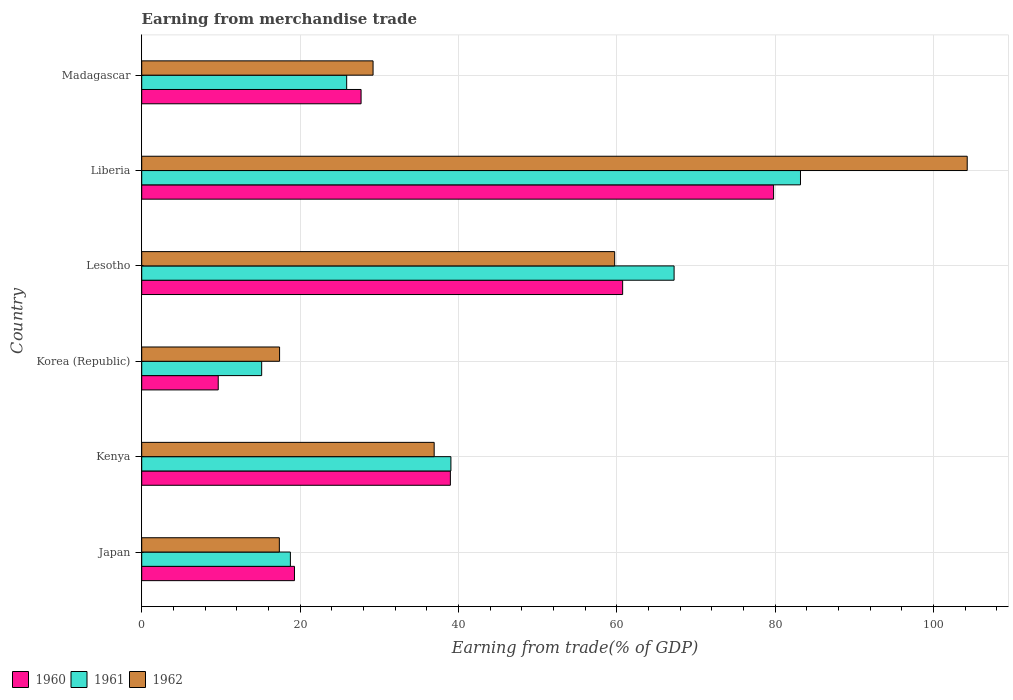How many different coloured bars are there?
Provide a short and direct response. 3. How many groups of bars are there?
Ensure brevity in your answer.  6. Are the number of bars per tick equal to the number of legend labels?
Give a very brief answer. Yes. Are the number of bars on each tick of the Y-axis equal?
Provide a short and direct response. Yes. How many bars are there on the 1st tick from the bottom?
Your answer should be compact. 3. What is the label of the 2nd group of bars from the top?
Make the answer very short. Liberia. What is the earnings from trade in 1960 in Lesotho?
Make the answer very short. 60.73. Across all countries, what is the maximum earnings from trade in 1961?
Ensure brevity in your answer.  83.19. Across all countries, what is the minimum earnings from trade in 1960?
Your response must be concise. 9.66. In which country was the earnings from trade in 1961 maximum?
Your answer should be very brief. Liberia. What is the total earnings from trade in 1961 in the graph?
Keep it short and to the point. 249.26. What is the difference between the earnings from trade in 1962 in Lesotho and that in Madagascar?
Make the answer very short. 30.51. What is the difference between the earnings from trade in 1962 in Lesotho and the earnings from trade in 1961 in Madagascar?
Provide a short and direct response. 33.84. What is the average earnings from trade in 1960 per country?
Provide a short and direct response. 39.36. What is the difference between the earnings from trade in 1961 and earnings from trade in 1960 in Lesotho?
Your response must be concise. 6.5. In how many countries, is the earnings from trade in 1961 greater than 40 %?
Your answer should be compact. 2. What is the ratio of the earnings from trade in 1961 in Japan to that in Korea (Republic)?
Give a very brief answer. 1.24. Is the earnings from trade in 1961 in Kenya less than that in Lesotho?
Provide a short and direct response. Yes. Is the difference between the earnings from trade in 1961 in Korea (Republic) and Liberia greater than the difference between the earnings from trade in 1960 in Korea (Republic) and Liberia?
Provide a succinct answer. Yes. What is the difference between the highest and the second highest earnings from trade in 1961?
Your response must be concise. 15.96. What is the difference between the highest and the lowest earnings from trade in 1962?
Offer a terse response. 86.86. Is the sum of the earnings from trade in 1962 in Japan and Kenya greater than the maximum earnings from trade in 1961 across all countries?
Offer a very short reply. No. What does the 3rd bar from the top in Liberia represents?
Offer a terse response. 1960. What does the 1st bar from the bottom in Liberia represents?
Provide a succinct answer. 1960. What is the difference between two consecutive major ticks on the X-axis?
Provide a short and direct response. 20. Does the graph contain grids?
Your answer should be very brief. Yes. Where does the legend appear in the graph?
Offer a terse response. Bottom left. What is the title of the graph?
Your response must be concise. Earning from merchandise trade. Does "2014" appear as one of the legend labels in the graph?
Provide a short and direct response. No. What is the label or title of the X-axis?
Ensure brevity in your answer.  Earning from trade(% of GDP). What is the label or title of the Y-axis?
Offer a terse response. Country. What is the Earning from trade(% of GDP) in 1960 in Japan?
Your answer should be compact. 19.29. What is the Earning from trade(% of GDP) in 1961 in Japan?
Ensure brevity in your answer.  18.77. What is the Earning from trade(% of GDP) of 1962 in Japan?
Give a very brief answer. 17.38. What is the Earning from trade(% of GDP) of 1960 in Kenya?
Ensure brevity in your answer.  38.98. What is the Earning from trade(% of GDP) in 1961 in Kenya?
Give a very brief answer. 39.04. What is the Earning from trade(% of GDP) of 1962 in Kenya?
Offer a very short reply. 36.93. What is the Earning from trade(% of GDP) of 1960 in Korea (Republic)?
Offer a terse response. 9.66. What is the Earning from trade(% of GDP) of 1961 in Korea (Republic)?
Offer a terse response. 15.15. What is the Earning from trade(% of GDP) of 1962 in Korea (Republic)?
Your answer should be compact. 17.41. What is the Earning from trade(% of GDP) in 1960 in Lesotho?
Keep it short and to the point. 60.73. What is the Earning from trade(% of GDP) in 1961 in Lesotho?
Offer a terse response. 67.23. What is the Earning from trade(% of GDP) of 1962 in Lesotho?
Ensure brevity in your answer.  59.72. What is the Earning from trade(% of GDP) in 1960 in Liberia?
Your answer should be compact. 79.79. What is the Earning from trade(% of GDP) in 1961 in Liberia?
Your response must be concise. 83.19. What is the Earning from trade(% of GDP) in 1962 in Liberia?
Offer a very short reply. 104.24. What is the Earning from trade(% of GDP) of 1960 in Madagascar?
Give a very brief answer. 27.7. What is the Earning from trade(% of GDP) of 1961 in Madagascar?
Your answer should be very brief. 25.88. What is the Earning from trade(% of GDP) in 1962 in Madagascar?
Offer a terse response. 29.21. Across all countries, what is the maximum Earning from trade(% of GDP) of 1960?
Ensure brevity in your answer.  79.79. Across all countries, what is the maximum Earning from trade(% of GDP) in 1961?
Offer a terse response. 83.19. Across all countries, what is the maximum Earning from trade(% of GDP) in 1962?
Give a very brief answer. 104.24. Across all countries, what is the minimum Earning from trade(% of GDP) in 1960?
Ensure brevity in your answer.  9.66. Across all countries, what is the minimum Earning from trade(% of GDP) in 1961?
Your answer should be very brief. 15.15. Across all countries, what is the minimum Earning from trade(% of GDP) in 1962?
Give a very brief answer. 17.38. What is the total Earning from trade(% of GDP) in 1960 in the graph?
Provide a short and direct response. 236.14. What is the total Earning from trade(% of GDP) in 1961 in the graph?
Keep it short and to the point. 249.26. What is the total Earning from trade(% of GDP) in 1962 in the graph?
Keep it short and to the point. 264.89. What is the difference between the Earning from trade(% of GDP) in 1960 in Japan and that in Kenya?
Your answer should be compact. -19.69. What is the difference between the Earning from trade(% of GDP) in 1961 in Japan and that in Kenya?
Make the answer very short. -20.27. What is the difference between the Earning from trade(% of GDP) in 1962 in Japan and that in Kenya?
Your answer should be compact. -19.55. What is the difference between the Earning from trade(% of GDP) in 1960 in Japan and that in Korea (Republic)?
Your answer should be compact. 9.63. What is the difference between the Earning from trade(% of GDP) of 1961 in Japan and that in Korea (Republic)?
Give a very brief answer. 3.63. What is the difference between the Earning from trade(% of GDP) of 1962 in Japan and that in Korea (Republic)?
Offer a very short reply. -0.03. What is the difference between the Earning from trade(% of GDP) of 1960 in Japan and that in Lesotho?
Offer a very short reply. -41.44. What is the difference between the Earning from trade(% of GDP) in 1961 in Japan and that in Lesotho?
Ensure brevity in your answer.  -48.45. What is the difference between the Earning from trade(% of GDP) in 1962 in Japan and that in Lesotho?
Provide a short and direct response. -42.34. What is the difference between the Earning from trade(% of GDP) in 1960 in Japan and that in Liberia?
Make the answer very short. -60.5. What is the difference between the Earning from trade(% of GDP) of 1961 in Japan and that in Liberia?
Provide a succinct answer. -64.41. What is the difference between the Earning from trade(% of GDP) in 1962 in Japan and that in Liberia?
Keep it short and to the point. -86.86. What is the difference between the Earning from trade(% of GDP) in 1960 in Japan and that in Madagascar?
Your answer should be compact. -8.41. What is the difference between the Earning from trade(% of GDP) of 1961 in Japan and that in Madagascar?
Give a very brief answer. -7.11. What is the difference between the Earning from trade(% of GDP) in 1962 in Japan and that in Madagascar?
Provide a succinct answer. -11.84. What is the difference between the Earning from trade(% of GDP) of 1960 in Kenya and that in Korea (Republic)?
Make the answer very short. 29.31. What is the difference between the Earning from trade(% of GDP) in 1961 in Kenya and that in Korea (Republic)?
Offer a very short reply. 23.9. What is the difference between the Earning from trade(% of GDP) of 1962 in Kenya and that in Korea (Republic)?
Your answer should be very brief. 19.52. What is the difference between the Earning from trade(% of GDP) in 1960 in Kenya and that in Lesotho?
Provide a succinct answer. -21.75. What is the difference between the Earning from trade(% of GDP) of 1961 in Kenya and that in Lesotho?
Provide a succinct answer. -28.18. What is the difference between the Earning from trade(% of GDP) of 1962 in Kenya and that in Lesotho?
Provide a succinct answer. -22.79. What is the difference between the Earning from trade(% of GDP) of 1960 in Kenya and that in Liberia?
Offer a very short reply. -40.82. What is the difference between the Earning from trade(% of GDP) of 1961 in Kenya and that in Liberia?
Offer a terse response. -44.14. What is the difference between the Earning from trade(% of GDP) in 1962 in Kenya and that in Liberia?
Offer a terse response. -67.31. What is the difference between the Earning from trade(% of GDP) of 1960 in Kenya and that in Madagascar?
Keep it short and to the point. 11.28. What is the difference between the Earning from trade(% of GDP) in 1961 in Kenya and that in Madagascar?
Ensure brevity in your answer.  13.16. What is the difference between the Earning from trade(% of GDP) in 1962 in Kenya and that in Madagascar?
Your answer should be compact. 7.72. What is the difference between the Earning from trade(% of GDP) in 1960 in Korea (Republic) and that in Lesotho?
Ensure brevity in your answer.  -51.07. What is the difference between the Earning from trade(% of GDP) of 1961 in Korea (Republic) and that in Lesotho?
Your response must be concise. -52.08. What is the difference between the Earning from trade(% of GDP) in 1962 in Korea (Republic) and that in Lesotho?
Make the answer very short. -42.32. What is the difference between the Earning from trade(% of GDP) of 1960 in Korea (Republic) and that in Liberia?
Ensure brevity in your answer.  -70.13. What is the difference between the Earning from trade(% of GDP) of 1961 in Korea (Republic) and that in Liberia?
Offer a terse response. -68.04. What is the difference between the Earning from trade(% of GDP) of 1962 in Korea (Republic) and that in Liberia?
Keep it short and to the point. -86.83. What is the difference between the Earning from trade(% of GDP) in 1960 in Korea (Republic) and that in Madagascar?
Provide a short and direct response. -18.04. What is the difference between the Earning from trade(% of GDP) in 1961 in Korea (Republic) and that in Madagascar?
Your response must be concise. -10.74. What is the difference between the Earning from trade(% of GDP) of 1962 in Korea (Republic) and that in Madagascar?
Give a very brief answer. -11.81. What is the difference between the Earning from trade(% of GDP) in 1960 in Lesotho and that in Liberia?
Your answer should be compact. -19.06. What is the difference between the Earning from trade(% of GDP) in 1961 in Lesotho and that in Liberia?
Keep it short and to the point. -15.96. What is the difference between the Earning from trade(% of GDP) in 1962 in Lesotho and that in Liberia?
Provide a short and direct response. -44.52. What is the difference between the Earning from trade(% of GDP) of 1960 in Lesotho and that in Madagascar?
Keep it short and to the point. 33.03. What is the difference between the Earning from trade(% of GDP) in 1961 in Lesotho and that in Madagascar?
Your answer should be compact. 41.35. What is the difference between the Earning from trade(% of GDP) of 1962 in Lesotho and that in Madagascar?
Keep it short and to the point. 30.51. What is the difference between the Earning from trade(% of GDP) in 1960 in Liberia and that in Madagascar?
Your answer should be very brief. 52.09. What is the difference between the Earning from trade(% of GDP) in 1961 in Liberia and that in Madagascar?
Provide a short and direct response. 57.31. What is the difference between the Earning from trade(% of GDP) in 1962 in Liberia and that in Madagascar?
Give a very brief answer. 75.03. What is the difference between the Earning from trade(% of GDP) of 1960 in Japan and the Earning from trade(% of GDP) of 1961 in Kenya?
Keep it short and to the point. -19.76. What is the difference between the Earning from trade(% of GDP) in 1960 in Japan and the Earning from trade(% of GDP) in 1962 in Kenya?
Keep it short and to the point. -17.64. What is the difference between the Earning from trade(% of GDP) in 1961 in Japan and the Earning from trade(% of GDP) in 1962 in Kenya?
Your answer should be very brief. -18.16. What is the difference between the Earning from trade(% of GDP) of 1960 in Japan and the Earning from trade(% of GDP) of 1961 in Korea (Republic)?
Keep it short and to the point. 4.14. What is the difference between the Earning from trade(% of GDP) of 1960 in Japan and the Earning from trade(% of GDP) of 1962 in Korea (Republic)?
Your answer should be compact. 1.88. What is the difference between the Earning from trade(% of GDP) in 1961 in Japan and the Earning from trade(% of GDP) in 1962 in Korea (Republic)?
Provide a short and direct response. 1.37. What is the difference between the Earning from trade(% of GDP) of 1960 in Japan and the Earning from trade(% of GDP) of 1961 in Lesotho?
Give a very brief answer. -47.94. What is the difference between the Earning from trade(% of GDP) of 1960 in Japan and the Earning from trade(% of GDP) of 1962 in Lesotho?
Provide a succinct answer. -40.44. What is the difference between the Earning from trade(% of GDP) in 1961 in Japan and the Earning from trade(% of GDP) in 1962 in Lesotho?
Offer a terse response. -40.95. What is the difference between the Earning from trade(% of GDP) in 1960 in Japan and the Earning from trade(% of GDP) in 1961 in Liberia?
Give a very brief answer. -63.9. What is the difference between the Earning from trade(% of GDP) of 1960 in Japan and the Earning from trade(% of GDP) of 1962 in Liberia?
Make the answer very short. -84.95. What is the difference between the Earning from trade(% of GDP) of 1961 in Japan and the Earning from trade(% of GDP) of 1962 in Liberia?
Your response must be concise. -85.47. What is the difference between the Earning from trade(% of GDP) of 1960 in Japan and the Earning from trade(% of GDP) of 1961 in Madagascar?
Provide a short and direct response. -6.59. What is the difference between the Earning from trade(% of GDP) in 1960 in Japan and the Earning from trade(% of GDP) in 1962 in Madagascar?
Your answer should be very brief. -9.93. What is the difference between the Earning from trade(% of GDP) in 1961 in Japan and the Earning from trade(% of GDP) in 1962 in Madagascar?
Keep it short and to the point. -10.44. What is the difference between the Earning from trade(% of GDP) in 1960 in Kenya and the Earning from trade(% of GDP) in 1961 in Korea (Republic)?
Make the answer very short. 23.83. What is the difference between the Earning from trade(% of GDP) of 1960 in Kenya and the Earning from trade(% of GDP) of 1962 in Korea (Republic)?
Provide a succinct answer. 21.57. What is the difference between the Earning from trade(% of GDP) in 1961 in Kenya and the Earning from trade(% of GDP) in 1962 in Korea (Republic)?
Give a very brief answer. 21.64. What is the difference between the Earning from trade(% of GDP) of 1960 in Kenya and the Earning from trade(% of GDP) of 1961 in Lesotho?
Offer a terse response. -28.25. What is the difference between the Earning from trade(% of GDP) of 1960 in Kenya and the Earning from trade(% of GDP) of 1962 in Lesotho?
Provide a succinct answer. -20.75. What is the difference between the Earning from trade(% of GDP) of 1961 in Kenya and the Earning from trade(% of GDP) of 1962 in Lesotho?
Your answer should be very brief. -20.68. What is the difference between the Earning from trade(% of GDP) of 1960 in Kenya and the Earning from trade(% of GDP) of 1961 in Liberia?
Provide a short and direct response. -44.21. What is the difference between the Earning from trade(% of GDP) of 1960 in Kenya and the Earning from trade(% of GDP) of 1962 in Liberia?
Your answer should be very brief. -65.27. What is the difference between the Earning from trade(% of GDP) in 1961 in Kenya and the Earning from trade(% of GDP) in 1962 in Liberia?
Your answer should be compact. -65.2. What is the difference between the Earning from trade(% of GDP) in 1960 in Kenya and the Earning from trade(% of GDP) in 1961 in Madagascar?
Your answer should be very brief. 13.09. What is the difference between the Earning from trade(% of GDP) of 1960 in Kenya and the Earning from trade(% of GDP) of 1962 in Madagascar?
Provide a succinct answer. 9.76. What is the difference between the Earning from trade(% of GDP) in 1961 in Kenya and the Earning from trade(% of GDP) in 1962 in Madagascar?
Offer a very short reply. 9.83. What is the difference between the Earning from trade(% of GDP) of 1960 in Korea (Republic) and the Earning from trade(% of GDP) of 1961 in Lesotho?
Offer a very short reply. -57.57. What is the difference between the Earning from trade(% of GDP) of 1960 in Korea (Republic) and the Earning from trade(% of GDP) of 1962 in Lesotho?
Your answer should be very brief. -50.06. What is the difference between the Earning from trade(% of GDP) of 1961 in Korea (Republic) and the Earning from trade(% of GDP) of 1962 in Lesotho?
Your answer should be very brief. -44.58. What is the difference between the Earning from trade(% of GDP) in 1960 in Korea (Republic) and the Earning from trade(% of GDP) in 1961 in Liberia?
Offer a very short reply. -73.53. What is the difference between the Earning from trade(% of GDP) of 1960 in Korea (Republic) and the Earning from trade(% of GDP) of 1962 in Liberia?
Your response must be concise. -94.58. What is the difference between the Earning from trade(% of GDP) in 1961 in Korea (Republic) and the Earning from trade(% of GDP) in 1962 in Liberia?
Ensure brevity in your answer.  -89.1. What is the difference between the Earning from trade(% of GDP) in 1960 in Korea (Republic) and the Earning from trade(% of GDP) in 1961 in Madagascar?
Provide a short and direct response. -16.22. What is the difference between the Earning from trade(% of GDP) of 1960 in Korea (Republic) and the Earning from trade(% of GDP) of 1962 in Madagascar?
Keep it short and to the point. -19.55. What is the difference between the Earning from trade(% of GDP) in 1961 in Korea (Republic) and the Earning from trade(% of GDP) in 1962 in Madagascar?
Your answer should be very brief. -14.07. What is the difference between the Earning from trade(% of GDP) in 1960 in Lesotho and the Earning from trade(% of GDP) in 1961 in Liberia?
Ensure brevity in your answer.  -22.46. What is the difference between the Earning from trade(% of GDP) in 1960 in Lesotho and the Earning from trade(% of GDP) in 1962 in Liberia?
Keep it short and to the point. -43.51. What is the difference between the Earning from trade(% of GDP) of 1961 in Lesotho and the Earning from trade(% of GDP) of 1962 in Liberia?
Your answer should be very brief. -37.01. What is the difference between the Earning from trade(% of GDP) of 1960 in Lesotho and the Earning from trade(% of GDP) of 1961 in Madagascar?
Ensure brevity in your answer.  34.85. What is the difference between the Earning from trade(% of GDP) of 1960 in Lesotho and the Earning from trade(% of GDP) of 1962 in Madagascar?
Your answer should be compact. 31.51. What is the difference between the Earning from trade(% of GDP) in 1961 in Lesotho and the Earning from trade(% of GDP) in 1962 in Madagascar?
Your answer should be compact. 38.01. What is the difference between the Earning from trade(% of GDP) in 1960 in Liberia and the Earning from trade(% of GDP) in 1961 in Madagascar?
Provide a short and direct response. 53.91. What is the difference between the Earning from trade(% of GDP) in 1960 in Liberia and the Earning from trade(% of GDP) in 1962 in Madagascar?
Provide a succinct answer. 50.58. What is the difference between the Earning from trade(% of GDP) of 1961 in Liberia and the Earning from trade(% of GDP) of 1962 in Madagascar?
Ensure brevity in your answer.  53.97. What is the average Earning from trade(% of GDP) in 1960 per country?
Offer a very short reply. 39.36. What is the average Earning from trade(% of GDP) in 1961 per country?
Provide a short and direct response. 41.54. What is the average Earning from trade(% of GDP) in 1962 per country?
Your answer should be very brief. 44.15. What is the difference between the Earning from trade(% of GDP) of 1960 and Earning from trade(% of GDP) of 1961 in Japan?
Provide a short and direct response. 0.51. What is the difference between the Earning from trade(% of GDP) of 1960 and Earning from trade(% of GDP) of 1962 in Japan?
Offer a very short reply. 1.91. What is the difference between the Earning from trade(% of GDP) in 1961 and Earning from trade(% of GDP) in 1962 in Japan?
Your response must be concise. 1.4. What is the difference between the Earning from trade(% of GDP) of 1960 and Earning from trade(% of GDP) of 1961 in Kenya?
Your answer should be compact. -0.07. What is the difference between the Earning from trade(% of GDP) in 1960 and Earning from trade(% of GDP) in 1962 in Kenya?
Your response must be concise. 2.04. What is the difference between the Earning from trade(% of GDP) in 1961 and Earning from trade(% of GDP) in 1962 in Kenya?
Ensure brevity in your answer.  2.11. What is the difference between the Earning from trade(% of GDP) of 1960 and Earning from trade(% of GDP) of 1961 in Korea (Republic)?
Offer a terse response. -5.48. What is the difference between the Earning from trade(% of GDP) in 1960 and Earning from trade(% of GDP) in 1962 in Korea (Republic)?
Give a very brief answer. -7.75. What is the difference between the Earning from trade(% of GDP) in 1961 and Earning from trade(% of GDP) in 1962 in Korea (Republic)?
Ensure brevity in your answer.  -2.26. What is the difference between the Earning from trade(% of GDP) of 1960 and Earning from trade(% of GDP) of 1961 in Lesotho?
Keep it short and to the point. -6.5. What is the difference between the Earning from trade(% of GDP) of 1960 and Earning from trade(% of GDP) of 1962 in Lesotho?
Provide a succinct answer. 1.01. What is the difference between the Earning from trade(% of GDP) in 1961 and Earning from trade(% of GDP) in 1962 in Lesotho?
Offer a terse response. 7.5. What is the difference between the Earning from trade(% of GDP) in 1960 and Earning from trade(% of GDP) in 1961 in Liberia?
Your response must be concise. -3.4. What is the difference between the Earning from trade(% of GDP) in 1960 and Earning from trade(% of GDP) in 1962 in Liberia?
Your response must be concise. -24.45. What is the difference between the Earning from trade(% of GDP) in 1961 and Earning from trade(% of GDP) in 1962 in Liberia?
Give a very brief answer. -21.05. What is the difference between the Earning from trade(% of GDP) of 1960 and Earning from trade(% of GDP) of 1961 in Madagascar?
Offer a terse response. 1.82. What is the difference between the Earning from trade(% of GDP) in 1960 and Earning from trade(% of GDP) in 1962 in Madagascar?
Your response must be concise. -1.51. What is the difference between the Earning from trade(% of GDP) of 1961 and Earning from trade(% of GDP) of 1962 in Madagascar?
Your answer should be very brief. -3.33. What is the ratio of the Earning from trade(% of GDP) in 1960 in Japan to that in Kenya?
Provide a succinct answer. 0.49. What is the ratio of the Earning from trade(% of GDP) in 1961 in Japan to that in Kenya?
Ensure brevity in your answer.  0.48. What is the ratio of the Earning from trade(% of GDP) of 1962 in Japan to that in Kenya?
Your answer should be compact. 0.47. What is the ratio of the Earning from trade(% of GDP) of 1960 in Japan to that in Korea (Republic)?
Your response must be concise. 2. What is the ratio of the Earning from trade(% of GDP) in 1961 in Japan to that in Korea (Republic)?
Keep it short and to the point. 1.24. What is the ratio of the Earning from trade(% of GDP) in 1960 in Japan to that in Lesotho?
Make the answer very short. 0.32. What is the ratio of the Earning from trade(% of GDP) in 1961 in Japan to that in Lesotho?
Your response must be concise. 0.28. What is the ratio of the Earning from trade(% of GDP) in 1962 in Japan to that in Lesotho?
Keep it short and to the point. 0.29. What is the ratio of the Earning from trade(% of GDP) of 1960 in Japan to that in Liberia?
Offer a terse response. 0.24. What is the ratio of the Earning from trade(% of GDP) in 1961 in Japan to that in Liberia?
Keep it short and to the point. 0.23. What is the ratio of the Earning from trade(% of GDP) in 1960 in Japan to that in Madagascar?
Offer a very short reply. 0.7. What is the ratio of the Earning from trade(% of GDP) in 1961 in Japan to that in Madagascar?
Give a very brief answer. 0.73. What is the ratio of the Earning from trade(% of GDP) in 1962 in Japan to that in Madagascar?
Offer a very short reply. 0.59. What is the ratio of the Earning from trade(% of GDP) in 1960 in Kenya to that in Korea (Republic)?
Provide a short and direct response. 4.03. What is the ratio of the Earning from trade(% of GDP) in 1961 in Kenya to that in Korea (Republic)?
Provide a short and direct response. 2.58. What is the ratio of the Earning from trade(% of GDP) in 1962 in Kenya to that in Korea (Republic)?
Provide a succinct answer. 2.12. What is the ratio of the Earning from trade(% of GDP) in 1960 in Kenya to that in Lesotho?
Offer a very short reply. 0.64. What is the ratio of the Earning from trade(% of GDP) of 1961 in Kenya to that in Lesotho?
Offer a very short reply. 0.58. What is the ratio of the Earning from trade(% of GDP) of 1962 in Kenya to that in Lesotho?
Offer a very short reply. 0.62. What is the ratio of the Earning from trade(% of GDP) of 1960 in Kenya to that in Liberia?
Keep it short and to the point. 0.49. What is the ratio of the Earning from trade(% of GDP) in 1961 in Kenya to that in Liberia?
Keep it short and to the point. 0.47. What is the ratio of the Earning from trade(% of GDP) of 1962 in Kenya to that in Liberia?
Ensure brevity in your answer.  0.35. What is the ratio of the Earning from trade(% of GDP) of 1960 in Kenya to that in Madagascar?
Offer a very short reply. 1.41. What is the ratio of the Earning from trade(% of GDP) of 1961 in Kenya to that in Madagascar?
Offer a very short reply. 1.51. What is the ratio of the Earning from trade(% of GDP) of 1962 in Kenya to that in Madagascar?
Offer a very short reply. 1.26. What is the ratio of the Earning from trade(% of GDP) of 1960 in Korea (Republic) to that in Lesotho?
Provide a short and direct response. 0.16. What is the ratio of the Earning from trade(% of GDP) in 1961 in Korea (Republic) to that in Lesotho?
Offer a very short reply. 0.23. What is the ratio of the Earning from trade(% of GDP) of 1962 in Korea (Republic) to that in Lesotho?
Offer a very short reply. 0.29. What is the ratio of the Earning from trade(% of GDP) in 1960 in Korea (Republic) to that in Liberia?
Make the answer very short. 0.12. What is the ratio of the Earning from trade(% of GDP) of 1961 in Korea (Republic) to that in Liberia?
Provide a succinct answer. 0.18. What is the ratio of the Earning from trade(% of GDP) of 1962 in Korea (Republic) to that in Liberia?
Offer a very short reply. 0.17. What is the ratio of the Earning from trade(% of GDP) in 1960 in Korea (Republic) to that in Madagascar?
Offer a very short reply. 0.35. What is the ratio of the Earning from trade(% of GDP) in 1961 in Korea (Republic) to that in Madagascar?
Your answer should be very brief. 0.59. What is the ratio of the Earning from trade(% of GDP) of 1962 in Korea (Republic) to that in Madagascar?
Offer a very short reply. 0.6. What is the ratio of the Earning from trade(% of GDP) in 1960 in Lesotho to that in Liberia?
Make the answer very short. 0.76. What is the ratio of the Earning from trade(% of GDP) of 1961 in Lesotho to that in Liberia?
Provide a succinct answer. 0.81. What is the ratio of the Earning from trade(% of GDP) of 1962 in Lesotho to that in Liberia?
Your response must be concise. 0.57. What is the ratio of the Earning from trade(% of GDP) of 1960 in Lesotho to that in Madagascar?
Provide a short and direct response. 2.19. What is the ratio of the Earning from trade(% of GDP) of 1961 in Lesotho to that in Madagascar?
Make the answer very short. 2.6. What is the ratio of the Earning from trade(% of GDP) in 1962 in Lesotho to that in Madagascar?
Offer a terse response. 2.04. What is the ratio of the Earning from trade(% of GDP) of 1960 in Liberia to that in Madagascar?
Offer a very short reply. 2.88. What is the ratio of the Earning from trade(% of GDP) of 1961 in Liberia to that in Madagascar?
Give a very brief answer. 3.21. What is the ratio of the Earning from trade(% of GDP) in 1962 in Liberia to that in Madagascar?
Your response must be concise. 3.57. What is the difference between the highest and the second highest Earning from trade(% of GDP) in 1960?
Make the answer very short. 19.06. What is the difference between the highest and the second highest Earning from trade(% of GDP) of 1961?
Provide a short and direct response. 15.96. What is the difference between the highest and the second highest Earning from trade(% of GDP) in 1962?
Keep it short and to the point. 44.52. What is the difference between the highest and the lowest Earning from trade(% of GDP) in 1960?
Keep it short and to the point. 70.13. What is the difference between the highest and the lowest Earning from trade(% of GDP) of 1961?
Ensure brevity in your answer.  68.04. What is the difference between the highest and the lowest Earning from trade(% of GDP) of 1962?
Offer a terse response. 86.86. 